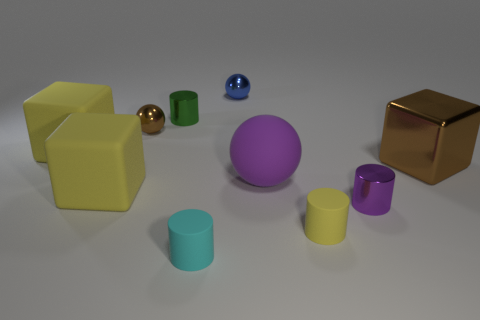Is the blue object made of the same material as the cyan thing?
Your answer should be very brief. No. What is the color of the other matte thing that is the same shape as the tiny blue thing?
Your response must be concise. Purple. There is a shiny cylinder right of the yellow cylinder; does it have the same color as the large ball?
Your response must be concise. Yes. There is a shiny object that is the same color as the matte ball; what shape is it?
Your response must be concise. Cylinder. What number of purple balls are made of the same material as the small purple cylinder?
Your answer should be compact. 0. What number of tiny metal cylinders are to the right of the small green shiny thing?
Make the answer very short. 1. The yellow matte cylinder is what size?
Keep it short and to the point. Small. The other shiny cylinder that is the same size as the purple cylinder is what color?
Offer a terse response. Green. Is there another matte ball of the same color as the large rubber ball?
Your answer should be very brief. No. What is the purple sphere made of?
Keep it short and to the point. Rubber. 